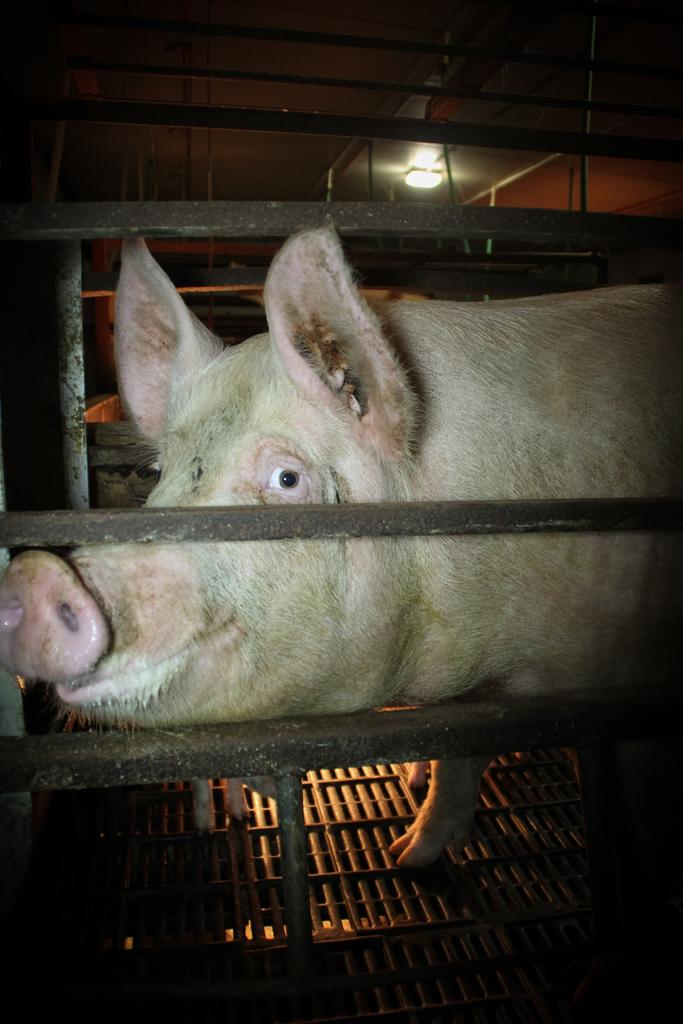What animal is present in the image? There is a pig in the image. What type of structures can be seen in the image? There are iron frames in the image. What can be seen at the top of the image? There is a light at the top of the image. What is the range of the man's view in the image? There is no man present in the image, so it is not possible to determine the range of his view. 